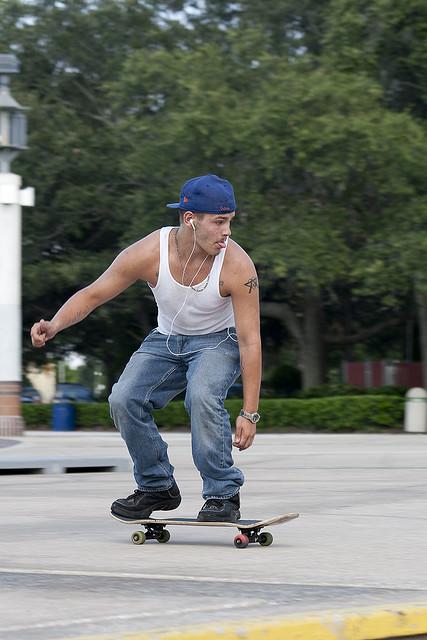Does the guy have a tattoo?
Concise answer only. Yes. What is this man riding on?
Concise answer only. Skateboard. How many tattoos can be seen on this man's body?
Concise answer only. 1. What color is his hat?
Concise answer only. Blue. Is the man's visor providing his face enough protection?
Answer briefly. No. 